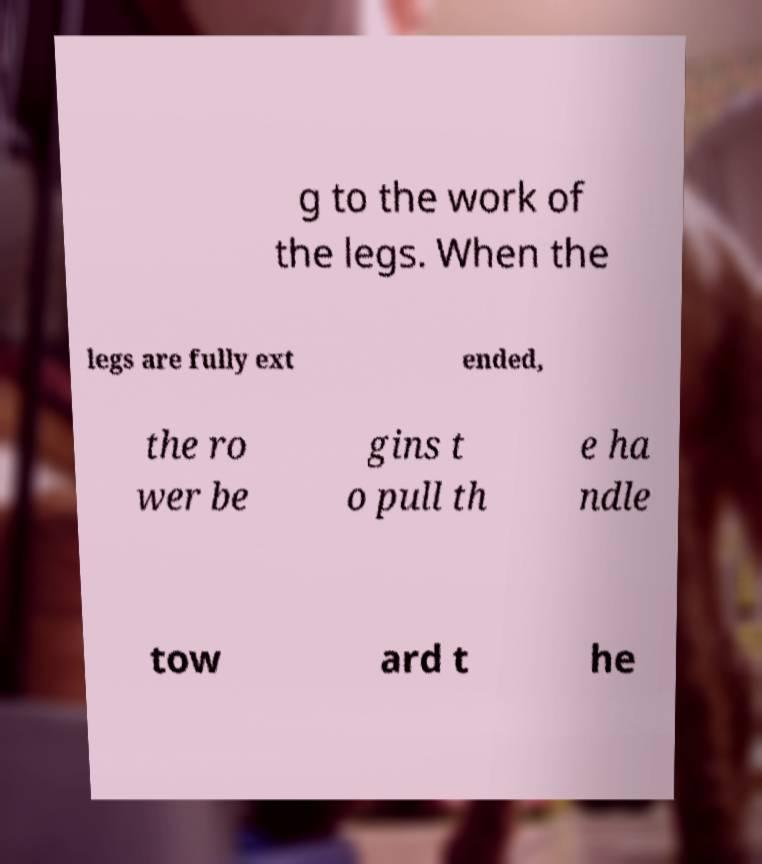I need the written content from this picture converted into text. Can you do that? g to the work of the legs. When the legs are fully ext ended, the ro wer be gins t o pull th e ha ndle tow ard t he 